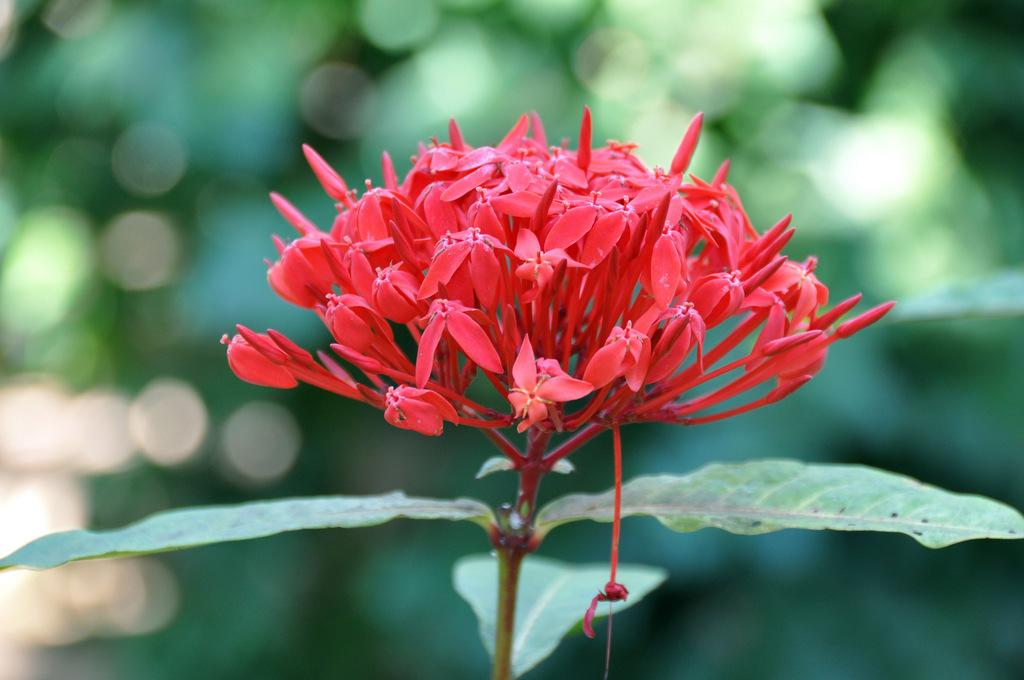What type of flowers are present in the image? There are tiny red flowers in the image. Can you describe the parts of the flowers? The flowers have stems and leaves. What can be observed about the background of the image? The background of the image is blurred. What type of music can be heard coming from the stove in the image? There is no stove or music present in the image; it features tiny red flowers with stems and leaves against a blurred background. 